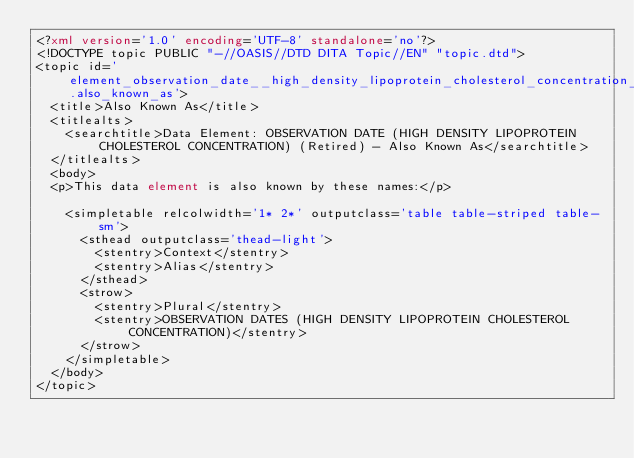Convert code to text. <code><loc_0><loc_0><loc_500><loc_500><_XML_><?xml version='1.0' encoding='UTF-8' standalone='no'?>
<!DOCTYPE topic PUBLIC "-//OASIS//DTD DITA Topic//EN" "topic.dtd">
<topic id='element_observation_date__high_density_lipoprotein_cholesterol_concentration_.also_known_as'>
  <title>Also Known As</title>
  <titlealts>
    <searchtitle>Data Element: OBSERVATION DATE (HIGH DENSITY LIPOPROTEIN CHOLESTEROL CONCENTRATION) (Retired) - Also Known As</searchtitle>
  </titlealts>
  <body>
  <p>This data element is also known by these names:</p>

    <simpletable relcolwidth='1* 2*' outputclass='table table-striped table-sm'>
      <sthead outputclass='thead-light'>
        <stentry>Context</stentry>
        <stentry>Alias</stentry>
      </sthead>
      <strow>
        <stentry>Plural</stentry>
        <stentry>OBSERVATION DATES (HIGH DENSITY LIPOPROTEIN CHOLESTEROL CONCENTRATION)</stentry>
      </strow>
    </simpletable>
  </body>
</topic></code> 